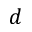<formula> <loc_0><loc_0><loc_500><loc_500>d</formula> 